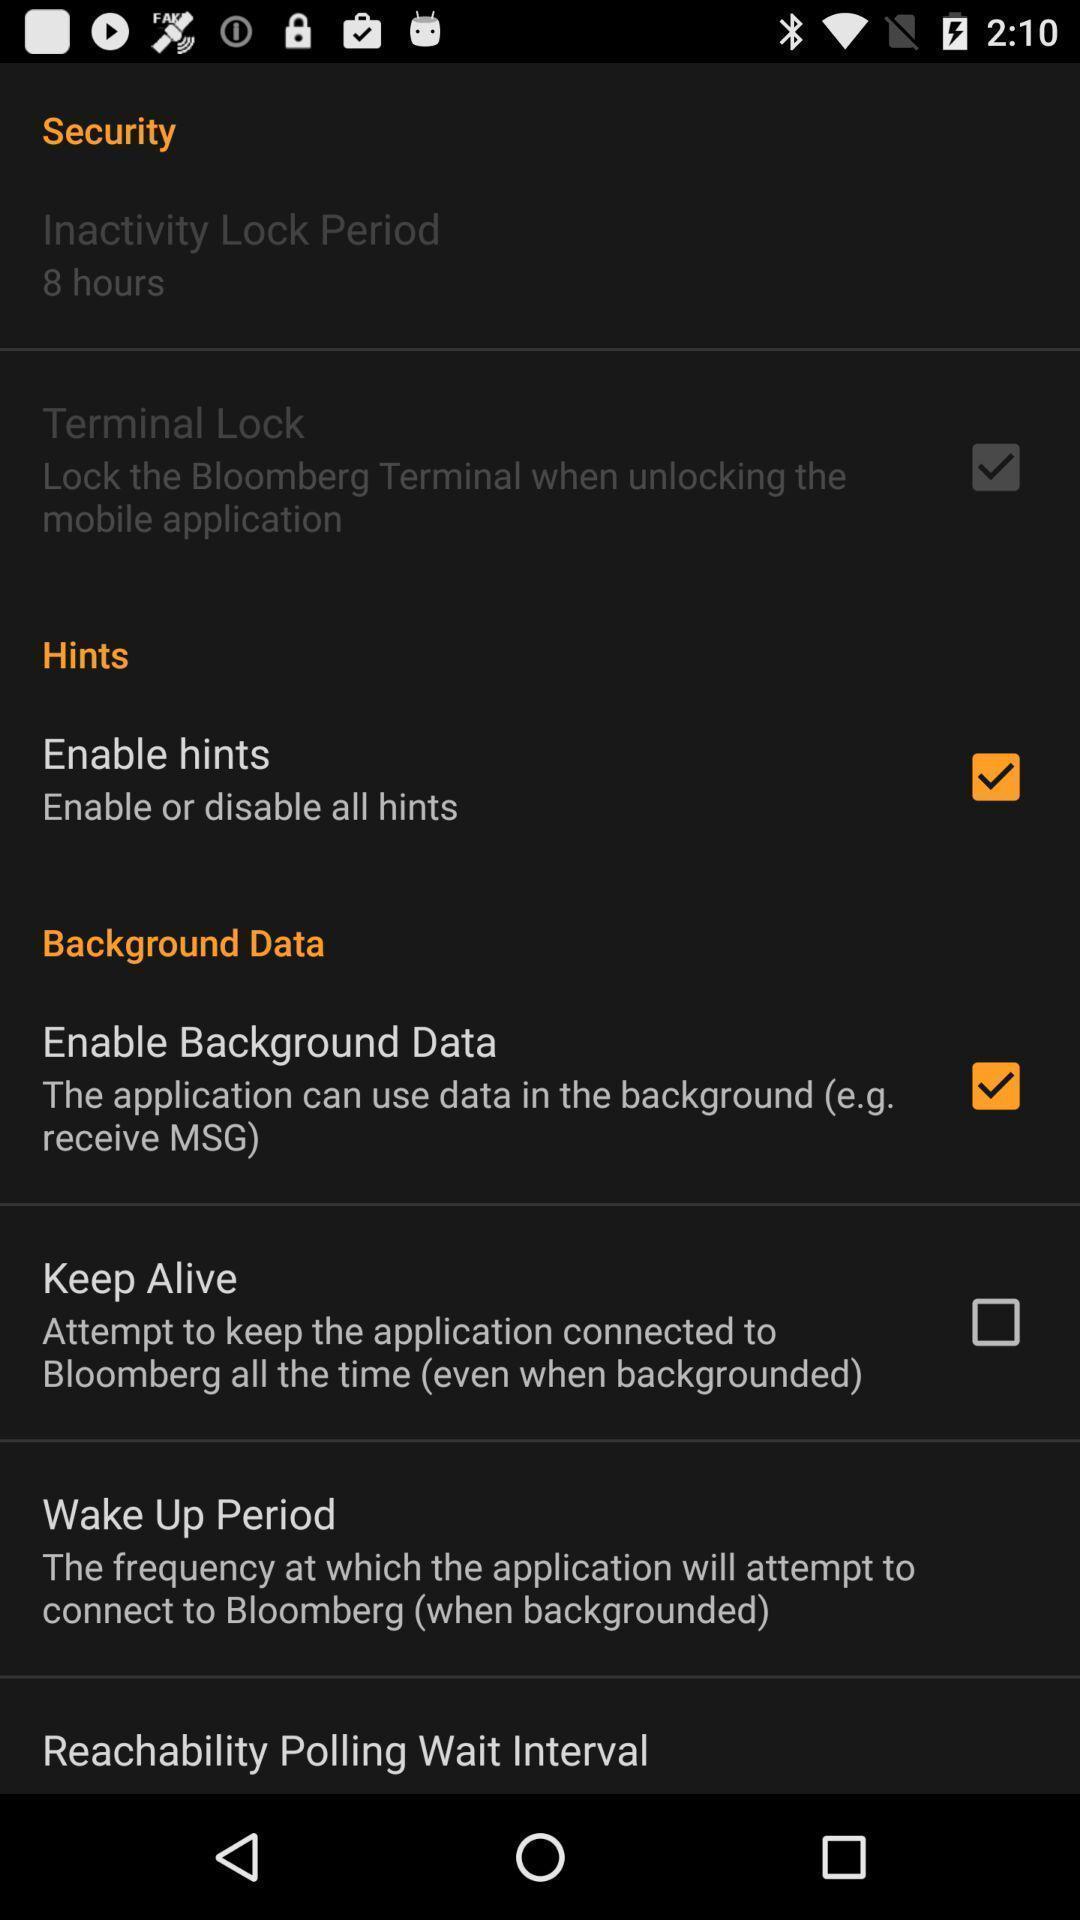Provide a textual representation of this image. Screen shows security settings on a device. 